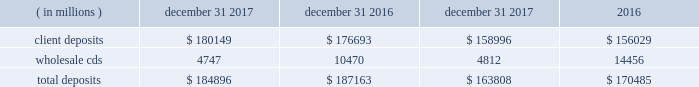Management 2019s discussion and analysis of financial condition and results of operations state street corporation | 90 table 30 : total deposits average balance december 31 years ended december 31 .
Short-term funding our on-balance sheet liquid assets are also an integral component of our liquidity management strategy .
These assets provide liquidity through maturities of the assets , but more importantly , they provide us with the ability to raise funds by pledging the securities as collateral for borrowings or through outright sales .
In addition , our access to the global capital markets gives us the ability to source incremental funding at reasonable rates of interest from wholesale investors .
As discussed earlier under 201casset liquidity , 201d state street bank's membership in the fhlb allows for advances of liquidity with varying terms against high-quality collateral .
Short-term secured funding also comes in the form of securities lent or sold under agreements to repurchase .
These transactions are short-term in nature , generally overnight , and are collateralized by high-quality investment securities .
These balances were $ 2.84 billion and $ 4.40 billion as of december 31 , 2017 and december 31 , 2016 , respectively .
State street bank currently maintains a line of credit with a financial institution of cad 1.40 billion , or approximately $ 1.11 billion as of december 31 , 2017 , to support its canadian securities processing operations .
The line of credit has no stated termination date and is cancelable by either party with prior notice .
As of december 31 , 2017 , there was no balance outstanding on this line of credit .
Long-term funding we have the ability to issue debt and equity securities under our current universal shelf registration to meet current commitments and business needs , including accommodating the transaction and cash management needs of our clients .
In addition , state street bank , a wholly owned subsidiary of the parent company , also has authorization to issue up to $ 5 billion in unsecured senior debt and an additional $ 500 million of subordinated debt .
Agency credit ratings our ability to maintain consistent access to liquidity is fostered by the maintenance of high investment-grade ratings as measured by the major independent credit rating agencies .
Factors essential to maintaining high credit ratings include : 2022 diverse and stable core earnings ; 2022 relative market position ; 2022 strong risk management ; 2022 strong capital ratios ; 2022 diverse liquidity sources , including the global capital markets and client deposits ; 2022 strong liquidity monitoring procedures ; and 2022 preparedness for current or future regulatory developments .
High ratings limit borrowing costs and enhance our liquidity by : 2022 providing assurance for unsecured funding and depositors ; 2022 increasing the potential market for our debt and improving our ability to offer products ; 2022 serving markets ; and 2022 engaging in transactions in which clients value high credit ratings .
A downgrade or reduction of our credit ratings could have a material adverse effect on our liquidity by restricting our ability to access the capital markets , which could increase the related cost of funds .
In turn , this could cause the sudden and large-scale withdrawal of unsecured deposits by our clients , which could lead to draw-downs of unfunded commitments to extend credit or trigger requirements under securities purchase commitments ; or require additional collateral or force terminations of certain trading derivative contracts .
A majority of our derivative contracts have been entered into under bilateral agreements with counterparties who may require us to post collateral or terminate the transactions based on changes in our credit ratings .
We assess the impact of these arrangements by determining the collateral that would be required assuming a downgrade by all rating agencies .
The additional collateral or termination payments related to our net derivative liabilities under these arrangements that could have been called by counterparties in the event of a downgrade in our credit ratings below levels specified in the agreements is disclosed in note 10 to the consolidated financial statements included under item 8 , financial statements and supplementary data , of this form 10-k .
Other funding sources , such as secured financing transactions and other margin requirements , for which there are no explicit triggers , could also be adversely affected. .
What is the percentage change in of total assets from 2016 to 2017? 
Computations: ((184896 - 187163) / 187163)
Answer: -0.01211. Management 2019s discussion and analysis of financial condition and results of operations state street corporation | 90 table 30 : total deposits average balance december 31 years ended december 31 .
Short-term funding our on-balance sheet liquid assets are also an integral component of our liquidity management strategy .
These assets provide liquidity through maturities of the assets , but more importantly , they provide us with the ability to raise funds by pledging the securities as collateral for borrowings or through outright sales .
In addition , our access to the global capital markets gives us the ability to source incremental funding at reasonable rates of interest from wholesale investors .
As discussed earlier under 201casset liquidity , 201d state street bank's membership in the fhlb allows for advances of liquidity with varying terms against high-quality collateral .
Short-term secured funding also comes in the form of securities lent or sold under agreements to repurchase .
These transactions are short-term in nature , generally overnight , and are collateralized by high-quality investment securities .
These balances were $ 2.84 billion and $ 4.40 billion as of december 31 , 2017 and december 31 , 2016 , respectively .
State street bank currently maintains a line of credit with a financial institution of cad 1.40 billion , or approximately $ 1.11 billion as of december 31 , 2017 , to support its canadian securities processing operations .
The line of credit has no stated termination date and is cancelable by either party with prior notice .
As of december 31 , 2017 , there was no balance outstanding on this line of credit .
Long-term funding we have the ability to issue debt and equity securities under our current universal shelf registration to meet current commitments and business needs , including accommodating the transaction and cash management needs of our clients .
In addition , state street bank , a wholly owned subsidiary of the parent company , also has authorization to issue up to $ 5 billion in unsecured senior debt and an additional $ 500 million of subordinated debt .
Agency credit ratings our ability to maintain consistent access to liquidity is fostered by the maintenance of high investment-grade ratings as measured by the major independent credit rating agencies .
Factors essential to maintaining high credit ratings include : 2022 diverse and stable core earnings ; 2022 relative market position ; 2022 strong risk management ; 2022 strong capital ratios ; 2022 diverse liquidity sources , including the global capital markets and client deposits ; 2022 strong liquidity monitoring procedures ; and 2022 preparedness for current or future regulatory developments .
High ratings limit borrowing costs and enhance our liquidity by : 2022 providing assurance for unsecured funding and depositors ; 2022 increasing the potential market for our debt and improving our ability to offer products ; 2022 serving markets ; and 2022 engaging in transactions in which clients value high credit ratings .
A downgrade or reduction of our credit ratings could have a material adverse effect on our liquidity by restricting our ability to access the capital markets , which could increase the related cost of funds .
In turn , this could cause the sudden and large-scale withdrawal of unsecured deposits by our clients , which could lead to draw-downs of unfunded commitments to extend credit or trigger requirements under securities purchase commitments ; or require additional collateral or force terminations of certain trading derivative contracts .
A majority of our derivative contracts have been entered into under bilateral agreements with counterparties who may require us to post collateral or terminate the transactions based on changes in our credit ratings .
We assess the impact of these arrangements by determining the collateral that would be required assuming a downgrade by all rating agencies .
The additional collateral or termination payments related to our net derivative liabilities under these arrangements that could have been called by counterparties in the event of a downgrade in our credit ratings below levels specified in the agreements is disclosed in note 10 to the consolidated financial statements included under item 8 , financial statements and supplementary data , of this form 10-k .
Other funding sources , such as secured financing transactions and other margin requirements , for which there are no explicit triggers , could also be adversely affected. .
What value of cad is equal to $ 1 usd? 
Rationale: i.e . what is exchange rate
Computations: (1.40 / 1.11)
Answer: 1.26126. 